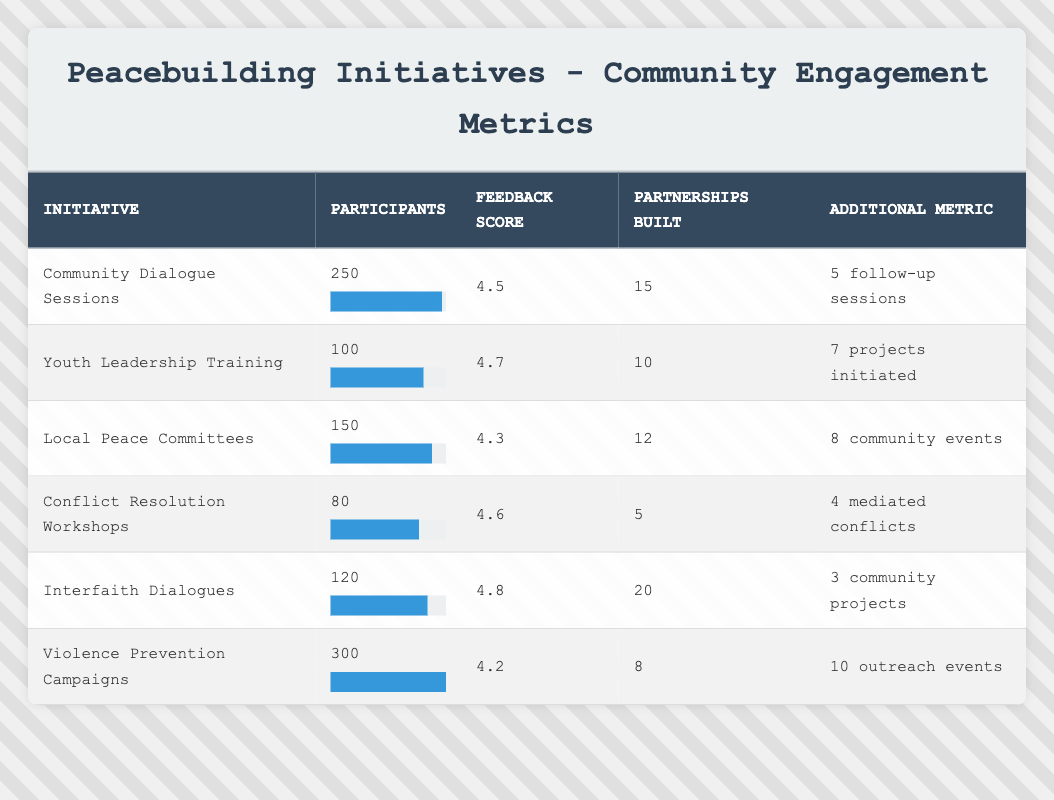What is the feedback score for the "Interfaith Dialogues" initiative? The feedback score is presented directly in the table for each initiative. For "Interfaith Dialogues," the score is listed as 4.8.
Answer: 4.8 How many participants were involved in the "Violence Prevention Campaigns"? The number of participants is listed in the table under the "Participants" column for each initiative. For "Violence Prevention Campaigns," there are 300 participants.
Answer: 300 Which initiative had the highest feedback score? By comparing the feedback scores across all initiatives in the table, "Interfaith Dialogues" has the highest score at 4.8.
Answer: Interfaith Dialogues What is the average number of partnerships built for all initiatives? To find the average, sum the partnerships built for each initiative: 15 + 10 + 12 + 5 + 20 + 8 = 70. There are 6 initiatives, so the average is 70 / 6 = 11.67.
Answer: 11.67 Is the feedback score for "Conflict Resolution Workshops" above 4.5? The feedback score for "Conflict Resolution Workshops" is stated as 4.6 in the table. Since 4.6 is greater than 4.5, the answer is yes.
Answer: Yes How many more participants attended the "Violence Prevention Campaigns" than the "Youth Leadership Training"? The number of participants for "Violence Prevention Campaigns" is 300, and for "Youth Leadership Training," it is 100. The difference is 300 - 100 = 200.
Answer: 200 Did "Local Peace Committees" have more or fewer partnerships built than "Conflict Resolution Workshops"? "Local Peace Committees" had 12 partnerships built, while "Conflict Resolution Workshops" had 5. Since 12 is greater than 5, the answer is more.
Answer: More What is the total number of community events initiated across all initiatives? The initiatives with community events are "Local Peace Committees" (8) and "Interfaith Dialogues" (3). Adding these gives 8 + 3 = 11 community events.
Answer: 11 What can be said about the average feedback score of initiatives with more than 150 participants compared to those with less? Initiatives with more than 150 participants are "Violence Prevention Campaigns" (4.2), and "Community Dialogue Sessions" (4.5), giving an average of (4.2 + 4.5) / 2 = 4.35. The initiatives with 150 or fewer participants are "Youth Leadership Training" (4.7), "Local Peace Committees" (4.3), "Conflict Resolution Workshops" (4.6), and "Interfaith Dialogues" (4.8), giving an average of (4.7 + 4.3 + 4.6 + 4.8) / 4 = 4.6. Comparing the two, 4.6 is greater, so the statement is true.
Answer: True 